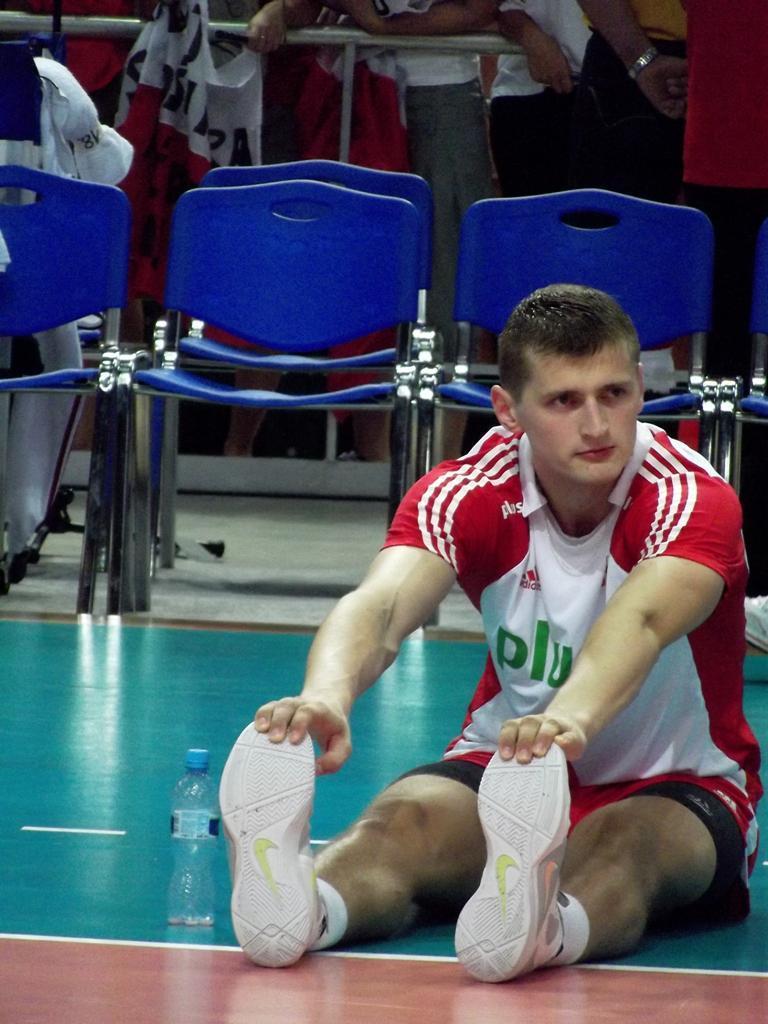Please provide a concise description of this image. In this image I can see a person wearing red, white and black colored dress and white colored shoe is sitting on the floor. I can see a water bottle beside him. In the background I can see few blue colored chairs, the railing and few persons standing. 